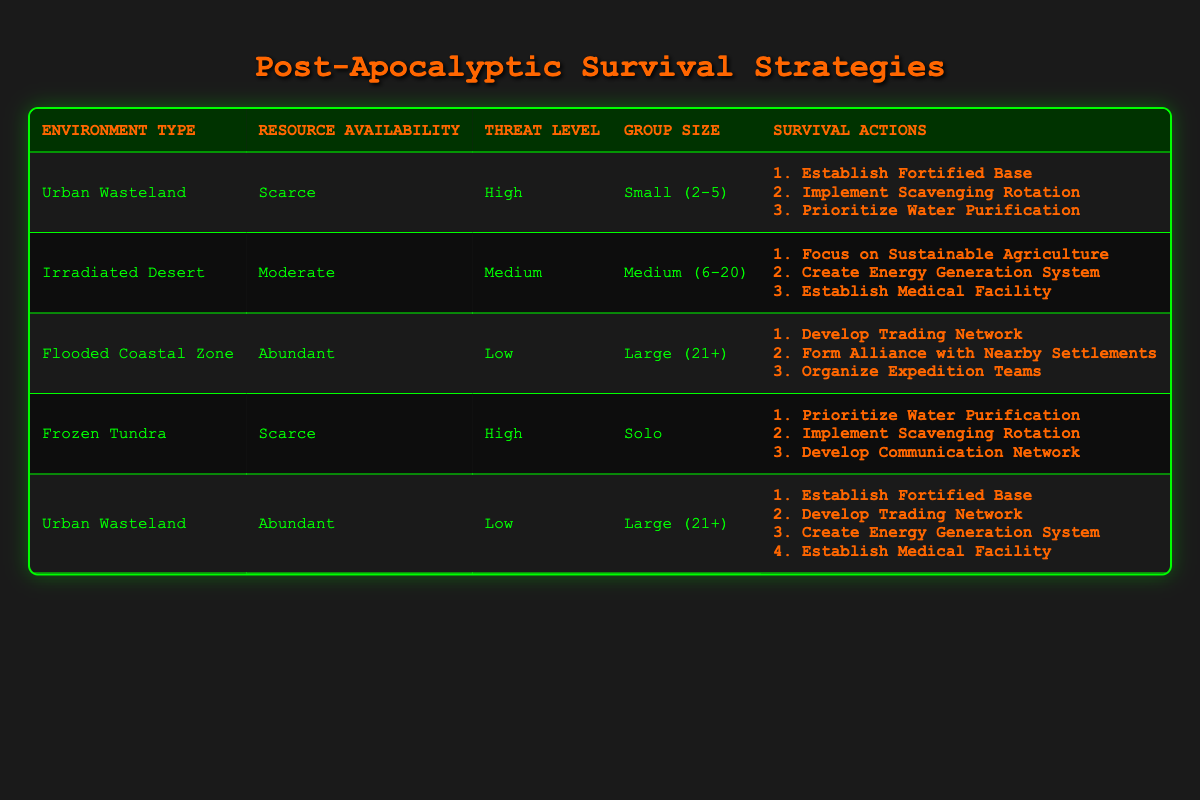What actions are suggested for a "Flooded Coastal Zone" with "Abundant" resources and "Low" threat level for a "Large (21+)" group? The table indicates that in a "Flooded Coastal Zone" with "Abundant" resources, a "Low" threat level, and a "Large (21+)" group size, the suggested actions include: "Develop Trading Network," "Form Alliance with Nearby Settlements," and "Organize Expedition Teams."
Answer: Develop Trading Network, Form Alliance with Nearby Settlements, Organize Expedition Teams Which environment type requires prioritization of water purification for a "Solo" group facing a "High" threat level? The table shows that "Frozen Tundra" is the environment type that requires prioritization of water purification for a "Solo" group facing a "High" threat level.
Answer: Frozen Tundra Is it true that a "Medium (6-20)" group in an "Irradiated Desert" with "Moderate" resources and "Medium" threat level has actions related to sustainable agriculture? Yes, the table indicates that a "Medium (6-20)" group in an "Irradiated Desert" with "Moderate" resources and "Medium" threat level should focus on "Sustainable Agriculture," among other actions.
Answer: Yes What is the total number of suggested actions for groups of "Small (2-5)" in "Urban Wasteland" with "Scarce" resources and "High" threat? For a "Small (2-5)" group in an "Urban Wasteland" with "Scarce" resources and "High" threat level, there are three suggested actions: "Establish Fortified Base," "Implement Scavenging Rotation," and "Prioritize Water Purification." So, the total number of actions is 3.
Answer: 3 If you have a "Large (21+)" group in an "Urban Wasteland" with "Abundant" resources and "Low" threat level, what actions can be taken? The table indicates that for a "Large (21+)" group in an "Urban Wasteland" with "Abundant" resources and "Low" threat level, the actions that can be taken are: "Establish Fortified Base," "Develop Trading Network," "Create Energy Generation System," and "Establish Medical Facility."
Answer: Establish Fortified Base, Develop Trading Network, Create Energy Generation System, Establish Medical Facility 